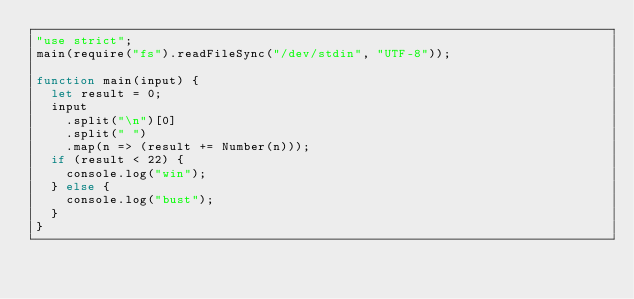Convert code to text. <code><loc_0><loc_0><loc_500><loc_500><_JavaScript_>"use strict";
main(require("fs").readFileSync("/dev/stdin", "UTF-8"));

function main(input) {
  let result = 0;
  input
    .split("\n")[0]
    .split(" ")
    .map(n => (result += Number(n)));
  if (result < 22) {
    console.log("win");
  } else {
    console.log("bust");
  }
}
</code> 